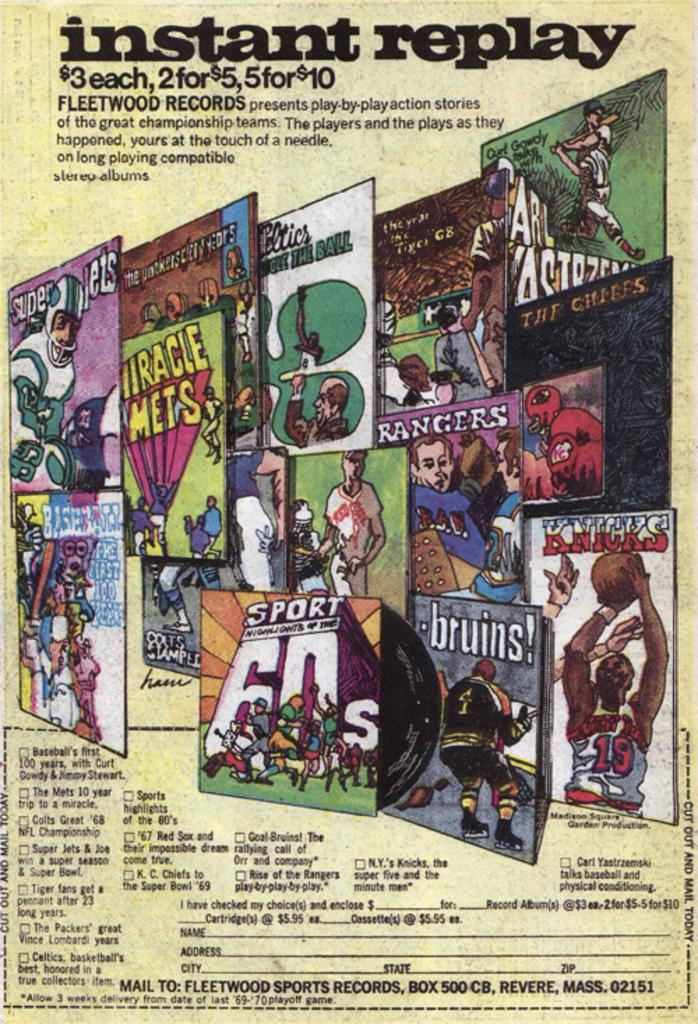<image>
Give a short and clear explanation of the subsequent image. a poster that has instant replay written on it 